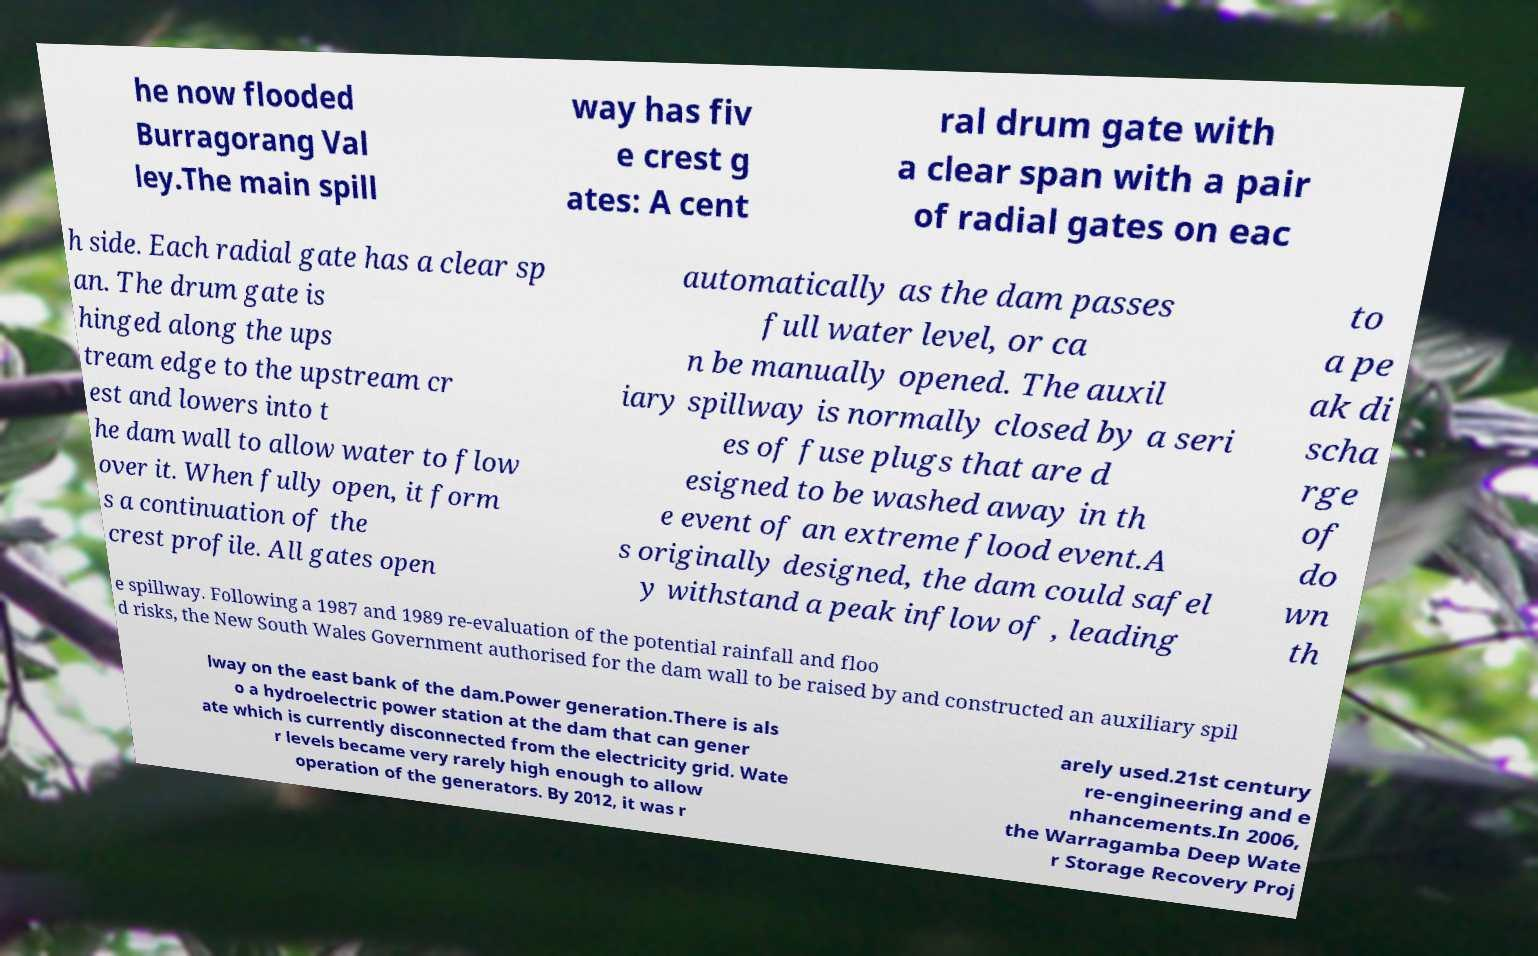Please identify and transcribe the text found in this image. he now flooded Burragorang Val ley.The main spill way has fiv e crest g ates: A cent ral drum gate with a clear span with a pair of radial gates on eac h side. Each radial gate has a clear sp an. The drum gate is hinged along the ups tream edge to the upstream cr est and lowers into t he dam wall to allow water to flow over it. When fully open, it form s a continuation of the crest profile. All gates open automatically as the dam passes full water level, or ca n be manually opened. The auxil iary spillway is normally closed by a seri es of fuse plugs that are d esigned to be washed away in th e event of an extreme flood event.A s originally designed, the dam could safel y withstand a peak inflow of , leading to a pe ak di scha rge of do wn th e spillway. Following a 1987 and 1989 re-evaluation of the potential rainfall and floo d risks, the New South Wales Government authorised for the dam wall to be raised by and constructed an auxiliary spil lway on the east bank of the dam.Power generation.There is als o a hydroelectric power station at the dam that can gener ate which is currently disconnected from the electricity grid. Wate r levels became very rarely high enough to allow operation of the generators. By 2012, it was r arely used.21st century re-engineering and e nhancements.In 2006, the Warragamba Deep Wate r Storage Recovery Proj 